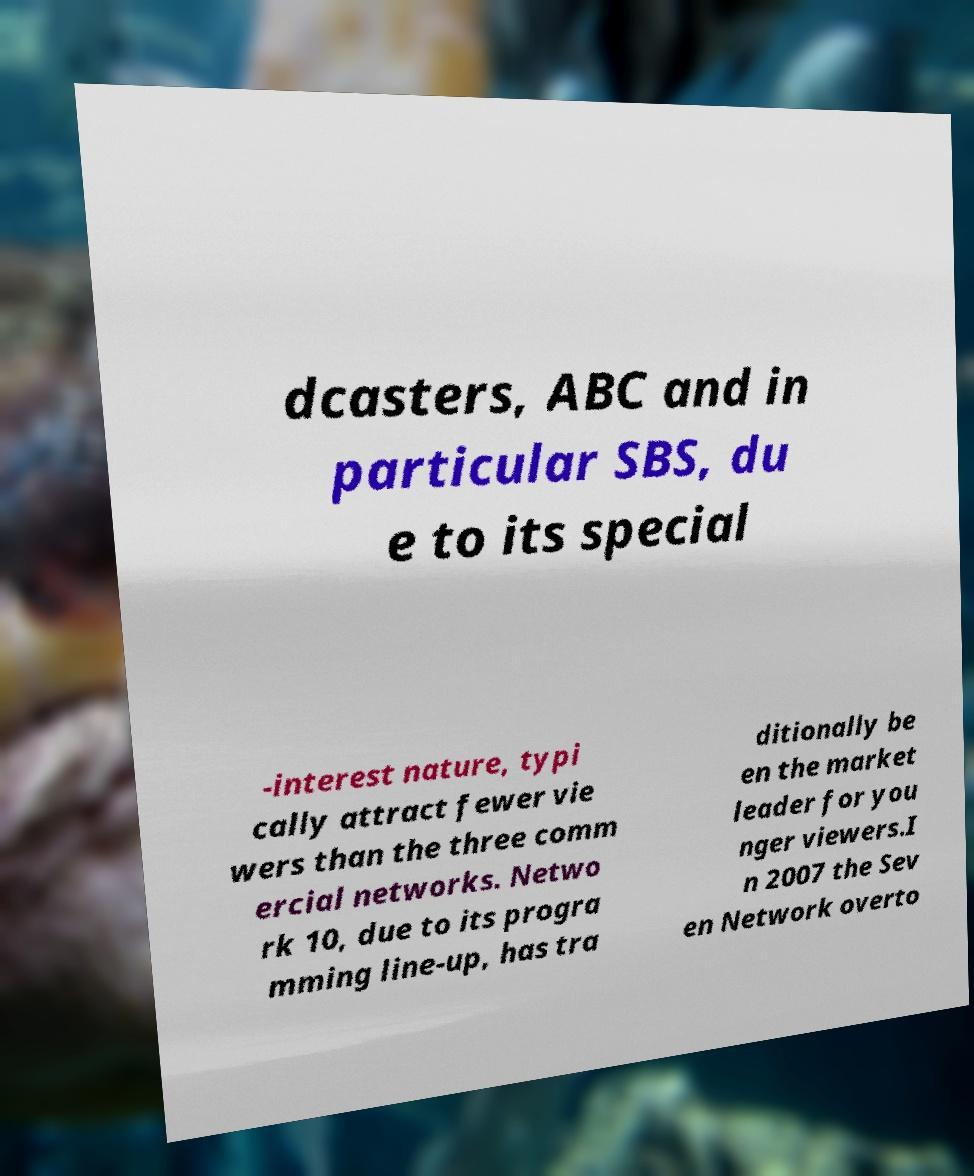I need the written content from this picture converted into text. Can you do that? dcasters, ABC and in particular SBS, du e to its special -interest nature, typi cally attract fewer vie wers than the three comm ercial networks. Netwo rk 10, due to its progra mming line-up, has tra ditionally be en the market leader for you nger viewers.I n 2007 the Sev en Network overto 